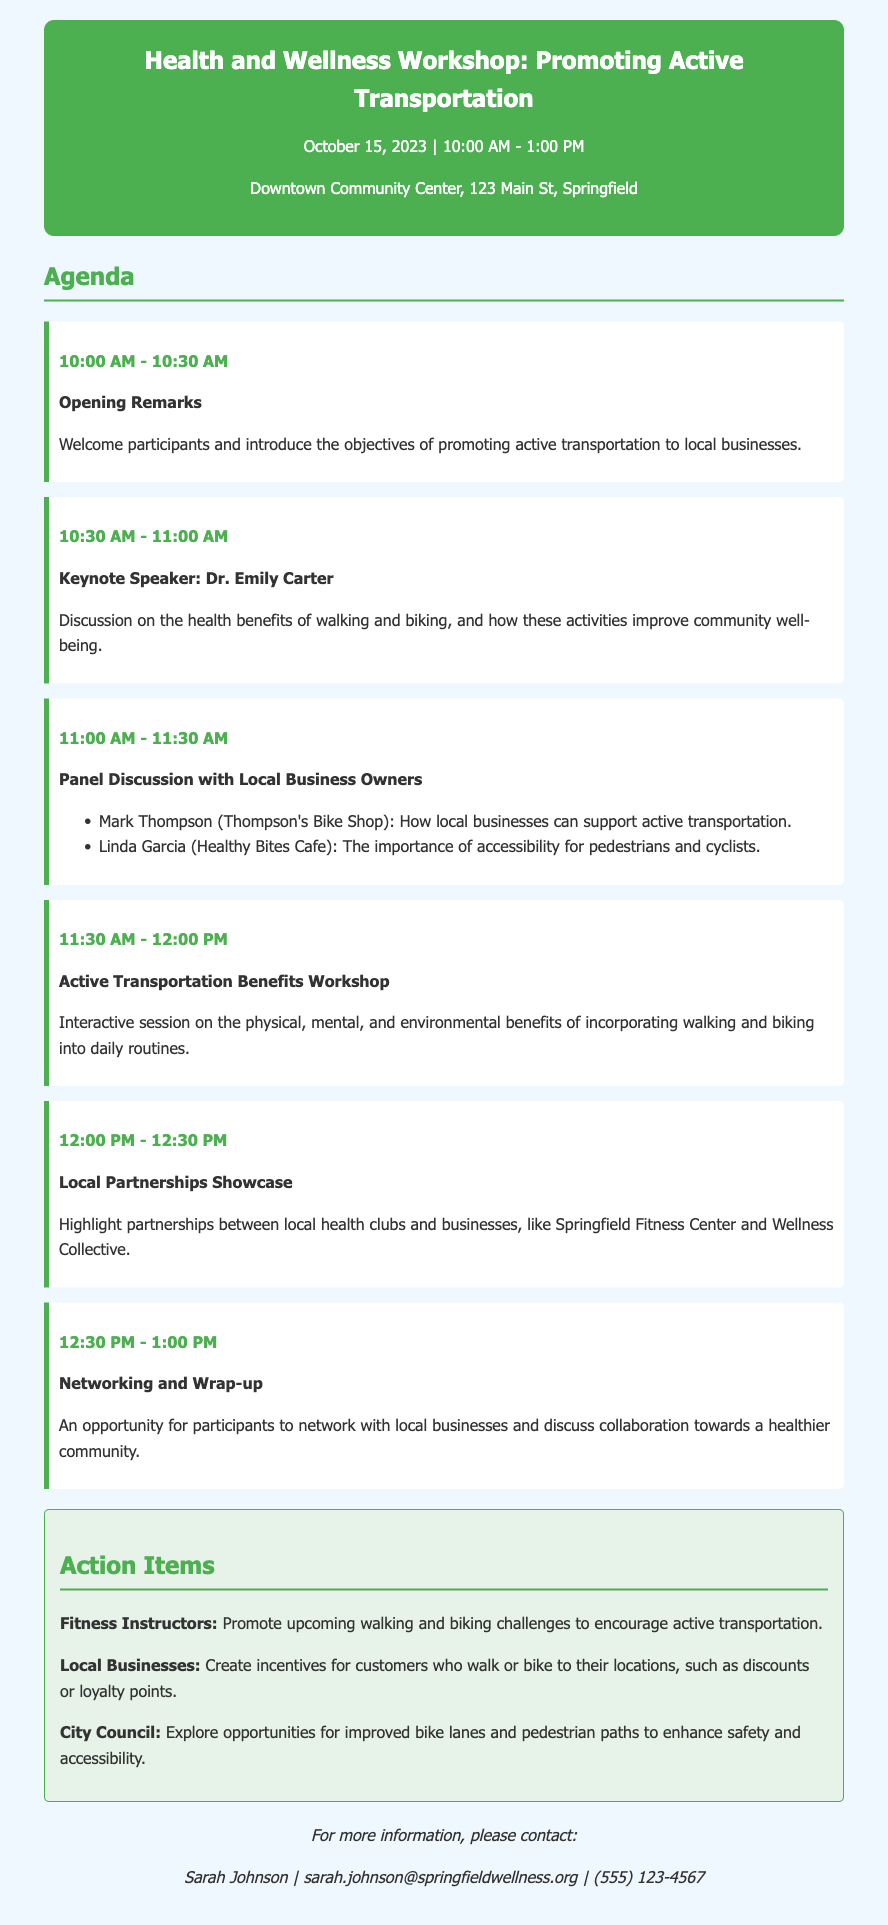What is the date of the workshop? The document mentions the workshop date as October 15, 2023.
Answer: October 15, 2023 What time does the workshop start? The workshop start time is specified as 10:00 AM.
Answer: 10:00 AM Who is the keynote speaker? The keynote speaker mentioned in the agenda is Dr. Emily Carter.
Answer: Dr. Emily Carter What local business is represented by Mark Thompson? Mark Thompson represents Thompson's Bike Shop.
Answer: Thompson's Bike Shop What is one benefit of active transportation discussed in the workshop? The document mentions physical, mental, and environmental benefits, focusing on the benefits of walking and biking.
Answer: Physical, mental, and environmental benefits Which local health club is highlighted in the partnerships showcase? Springfield Fitness Center is mentioned in the local partnerships showcase.
Answer: Springfield Fitness Center What action item is assigned to fitness instructors? The action item for fitness instructors is to promote upcoming walking and biking challenges.
Answer: Promote upcoming walking and biking challenges What is a recommendation for local businesses? The document recommends that local businesses create incentives for customers who walk or bike to their locations.
Answer: Create incentives for customers What is the duration of the panel discussion? The duration for the panel discussion is indicated as 30 minutes, from 11:00 AM to 11:30 AM.
Answer: 30 minutes What is provided for more information at the end of the document? The end of the document provides contact information for Sarah Johnson.
Answer: Contact information for Sarah Johnson 